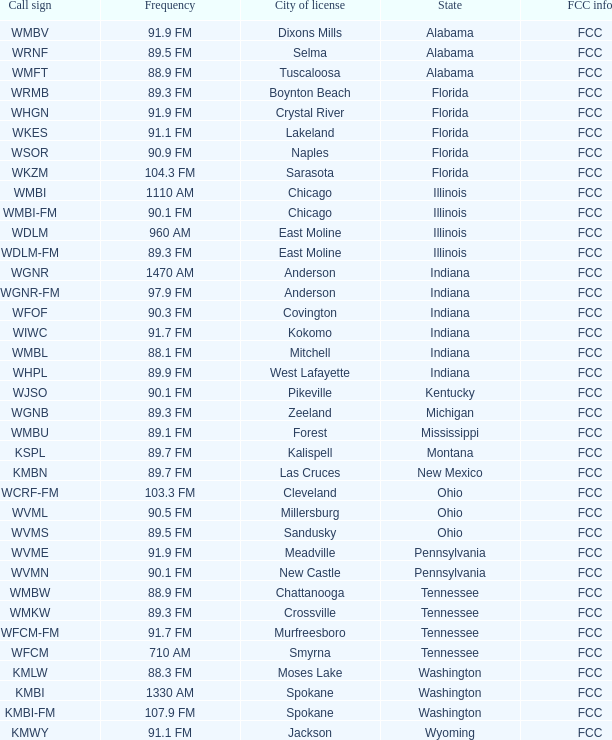At what frequency is the radio station wgnr-fm broadcasted? 97.9 FM. 